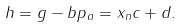<formula> <loc_0><loc_0><loc_500><loc_500>h = g - b p _ { a } = x _ { n } c + d .</formula> 